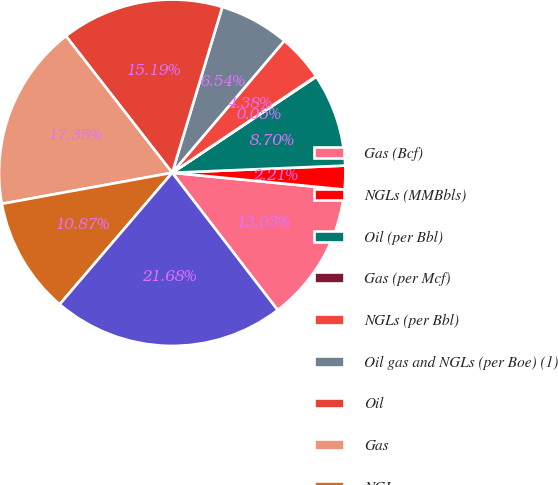Convert chart. <chart><loc_0><loc_0><loc_500><loc_500><pie_chart><fcel>Gas (Bcf)<fcel>NGLs (MMBbls)<fcel>Oil (per Bbl)<fcel>Gas (per Mcf)<fcel>NGLs (per Bbl)<fcel>Oil gas and NGLs (per Boe) (1)<fcel>Oil<fcel>Gas<fcel>NGLs<fcel>Oil gas and NGLs<nl><fcel>13.03%<fcel>2.21%<fcel>8.7%<fcel>0.05%<fcel>4.38%<fcel>6.54%<fcel>15.19%<fcel>17.35%<fcel>10.87%<fcel>21.68%<nl></chart> 